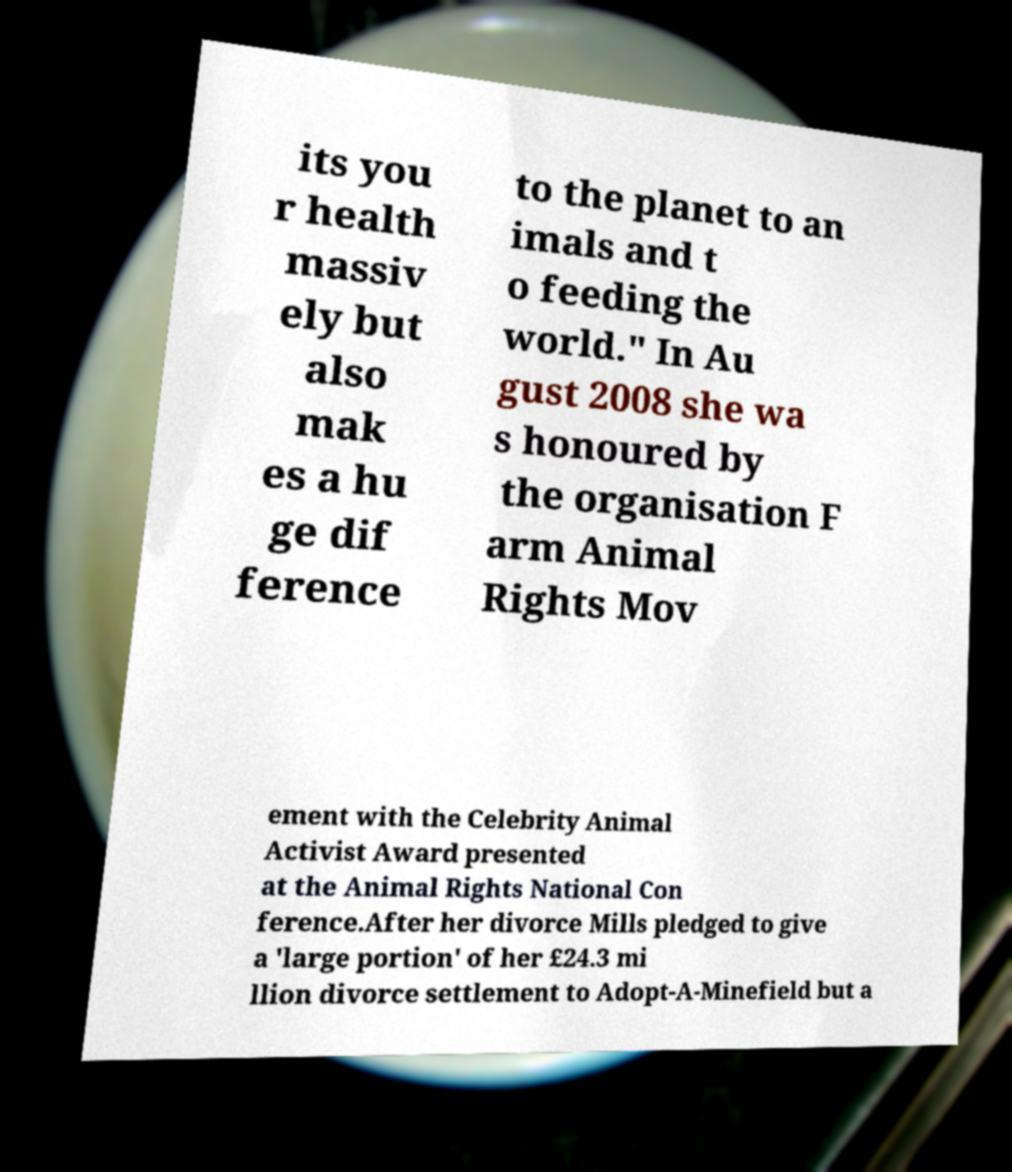Please read and relay the text visible in this image. What does it say? its you r health massiv ely but also mak es a hu ge dif ference to the planet to an imals and t o feeding the world." In Au gust 2008 she wa s honoured by the organisation F arm Animal Rights Mov ement with the Celebrity Animal Activist Award presented at the Animal Rights National Con ference.After her divorce Mills pledged to give a 'large portion' of her £24.3 mi llion divorce settlement to Adopt-A-Minefield but a 